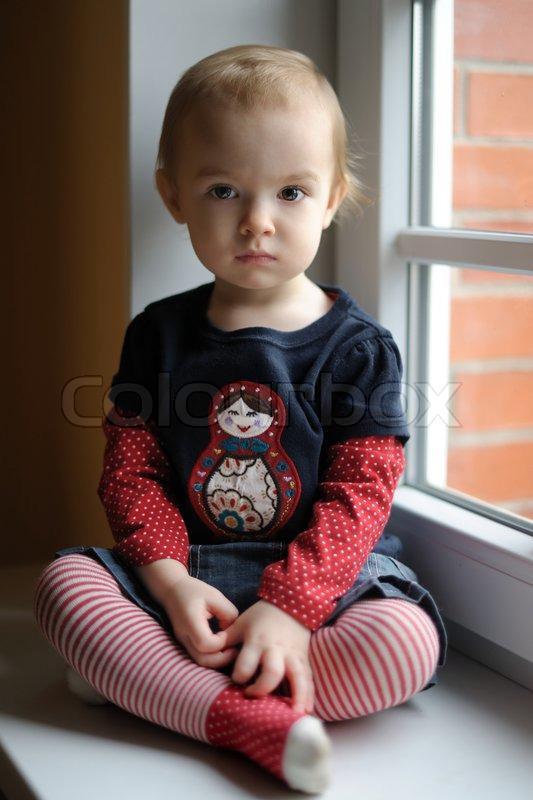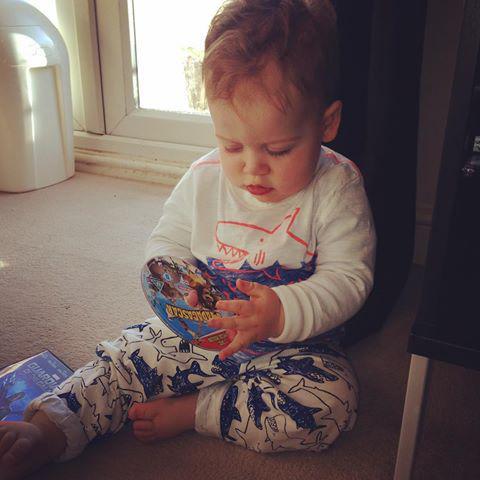The first image is the image on the left, the second image is the image on the right. For the images displayed, is the sentence "One image has an adult with a kid in their lap." factually correct? Answer yes or no. No. The first image is the image on the left, the second image is the image on the right. For the images shown, is this caption "One of the images has both a boy and a girl." true? Answer yes or no. No. 